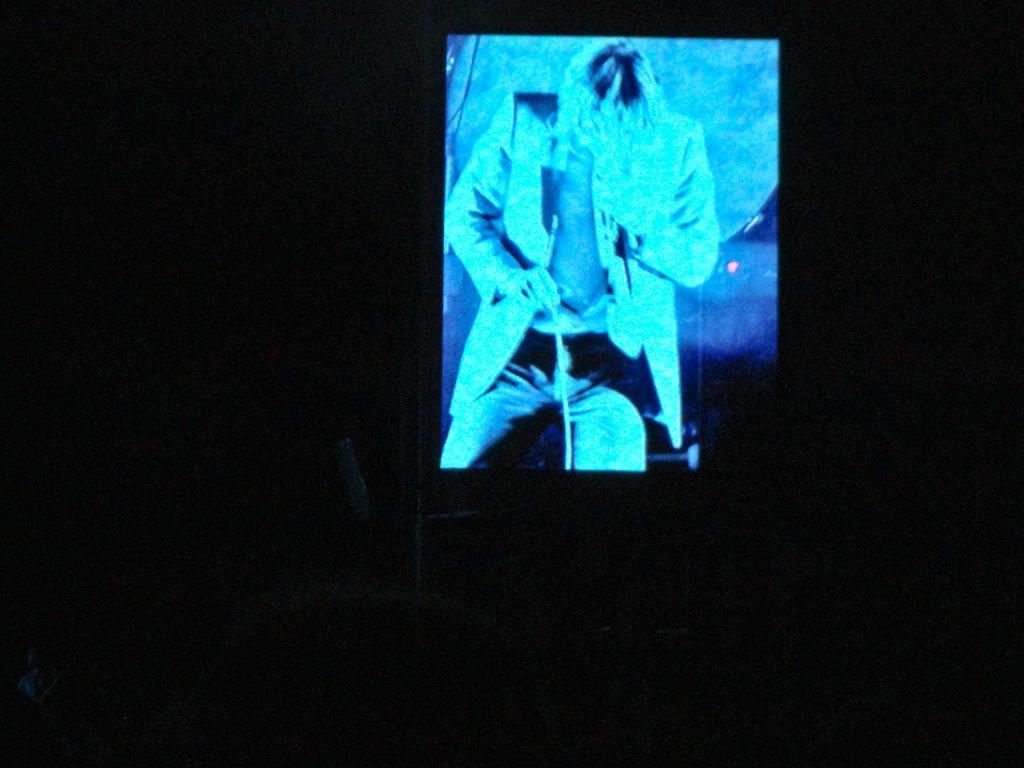Can you describe this image briefly? In this picture there is a projector screen. In the screen we can see a man who is wearing suit, trouser and watch. He is holding stick. At the bottom we can see the darkness. 